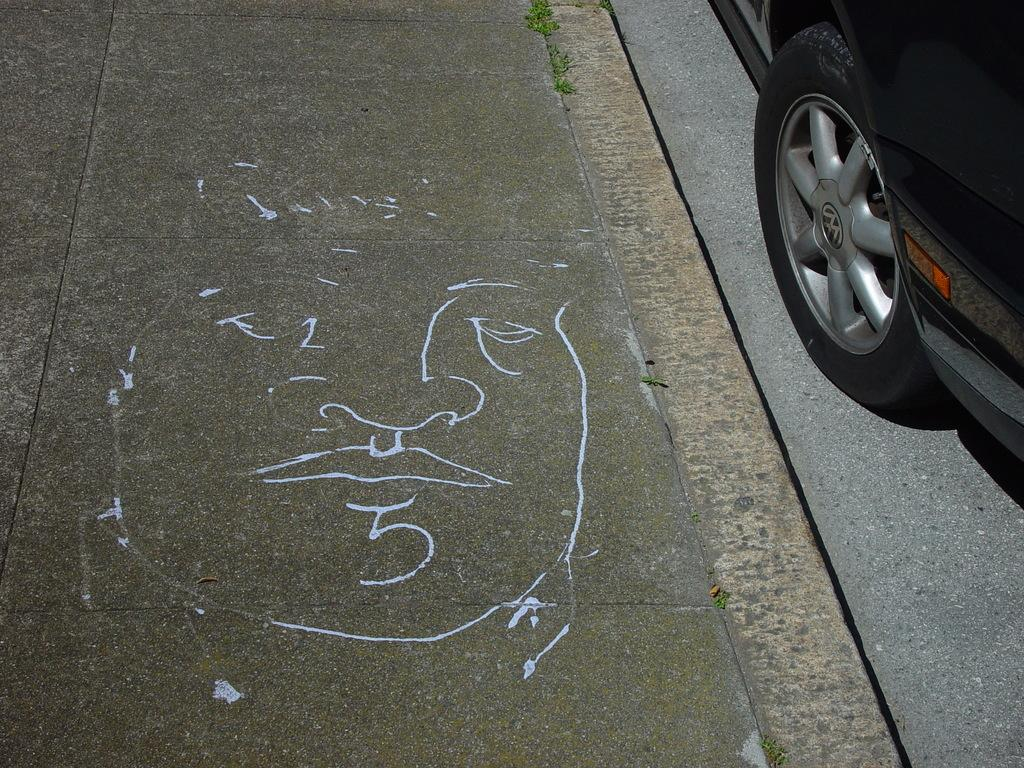What is the main subject of the image? There is a vehicle in the image. Can you describe the color of the vehicle? The vehicle is black in color. What can be seen in the background of the image? There are small plants in the background of the image. What is the color of the plants? The plants are green in color. Is there a record playing in the background of the image? There is no mention of a record or any sound source in the image, so it cannot be determined if one is present. 